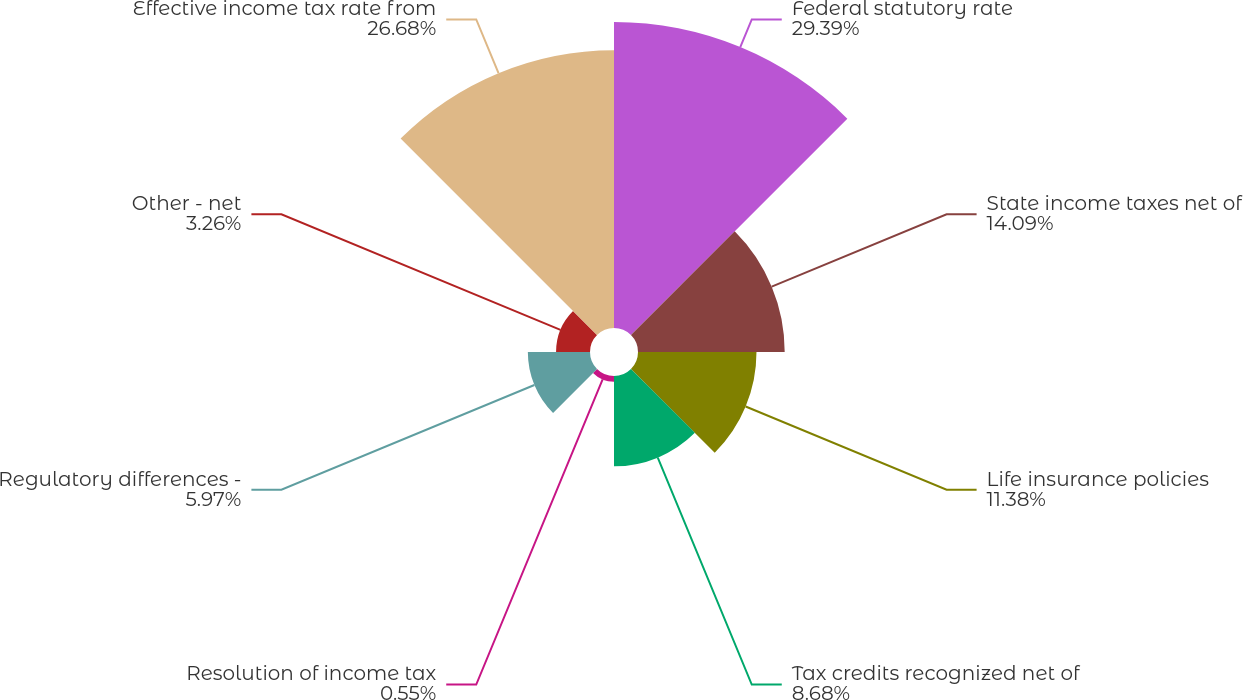<chart> <loc_0><loc_0><loc_500><loc_500><pie_chart><fcel>Federal statutory rate<fcel>State income taxes net of<fcel>Life insurance policies<fcel>Tax credits recognized net of<fcel>Resolution of income tax<fcel>Regulatory differences -<fcel>Other - net<fcel>Effective income tax rate from<nl><fcel>29.39%<fcel>14.09%<fcel>11.38%<fcel>8.68%<fcel>0.55%<fcel>5.97%<fcel>3.26%<fcel>26.68%<nl></chart> 